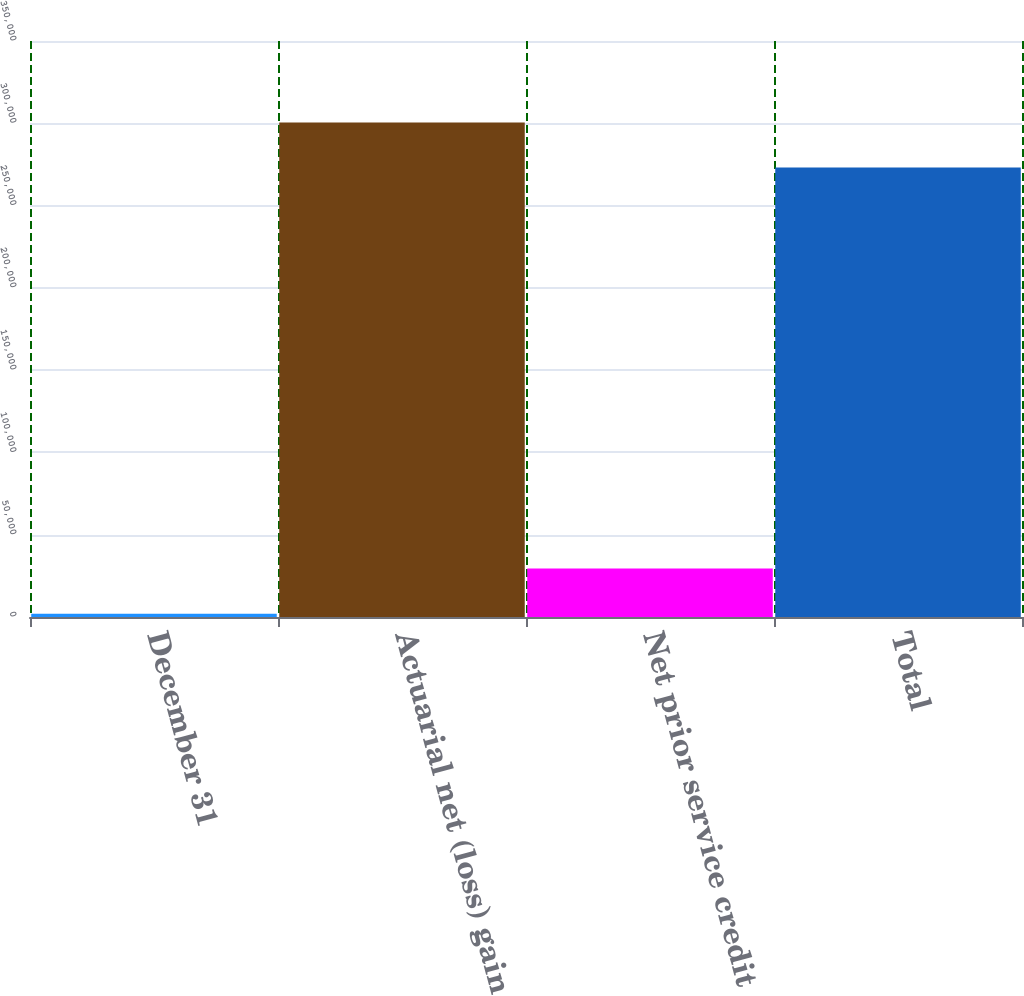Convert chart to OTSL. <chart><loc_0><loc_0><loc_500><loc_500><bar_chart><fcel>December 31<fcel>Actuarial net (loss) gain<fcel>Net prior service credit<fcel>Total<nl><fcel>2009<fcel>300539<fcel>29476<fcel>273072<nl></chart> 